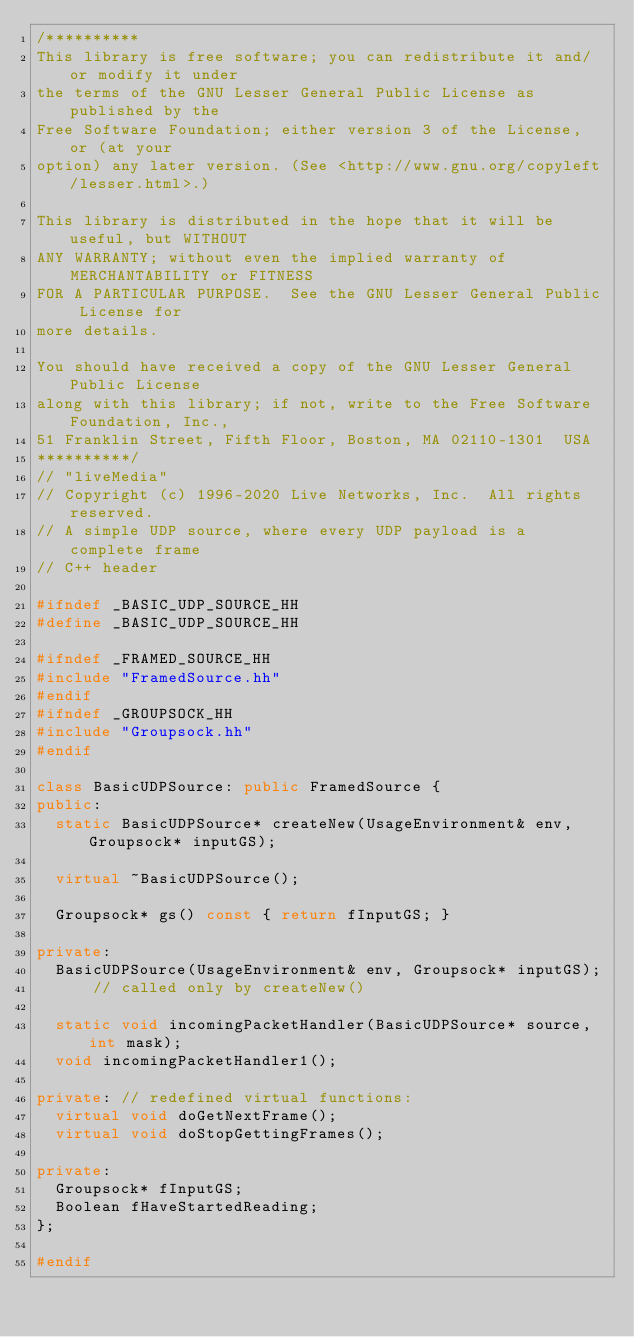<code> <loc_0><loc_0><loc_500><loc_500><_C++_>/**********
This library is free software; you can redistribute it and/or modify it under
the terms of the GNU Lesser General Public License as published by the
Free Software Foundation; either version 3 of the License, or (at your
option) any later version. (See <http://www.gnu.org/copyleft/lesser.html>.)

This library is distributed in the hope that it will be useful, but WITHOUT
ANY WARRANTY; without even the implied warranty of MERCHANTABILITY or FITNESS
FOR A PARTICULAR PURPOSE.  See the GNU Lesser General Public License for
more details.

You should have received a copy of the GNU Lesser General Public License
along with this library; if not, write to the Free Software Foundation, Inc.,
51 Franklin Street, Fifth Floor, Boston, MA 02110-1301  USA
**********/
// "liveMedia"
// Copyright (c) 1996-2020 Live Networks, Inc.  All rights reserved.
// A simple UDP source, where every UDP payload is a complete frame
// C++ header

#ifndef _BASIC_UDP_SOURCE_HH
#define _BASIC_UDP_SOURCE_HH

#ifndef _FRAMED_SOURCE_HH
#include "FramedSource.hh"
#endif
#ifndef _GROUPSOCK_HH
#include "Groupsock.hh"
#endif

class BasicUDPSource: public FramedSource {
public:
  static BasicUDPSource* createNew(UsageEnvironment& env, Groupsock* inputGS);

  virtual ~BasicUDPSource();

  Groupsock* gs() const { return fInputGS; }

private:
  BasicUDPSource(UsageEnvironment& env, Groupsock* inputGS);
      // called only by createNew()

  static void incomingPacketHandler(BasicUDPSource* source, int mask);
  void incomingPacketHandler1();

private: // redefined virtual functions:
  virtual void doGetNextFrame();
  virtual void doStopGettingFrames();

private:
  Groupsock* fInputGS;
  Boolean fHaveStartedReading;
};

#endif
</code> 